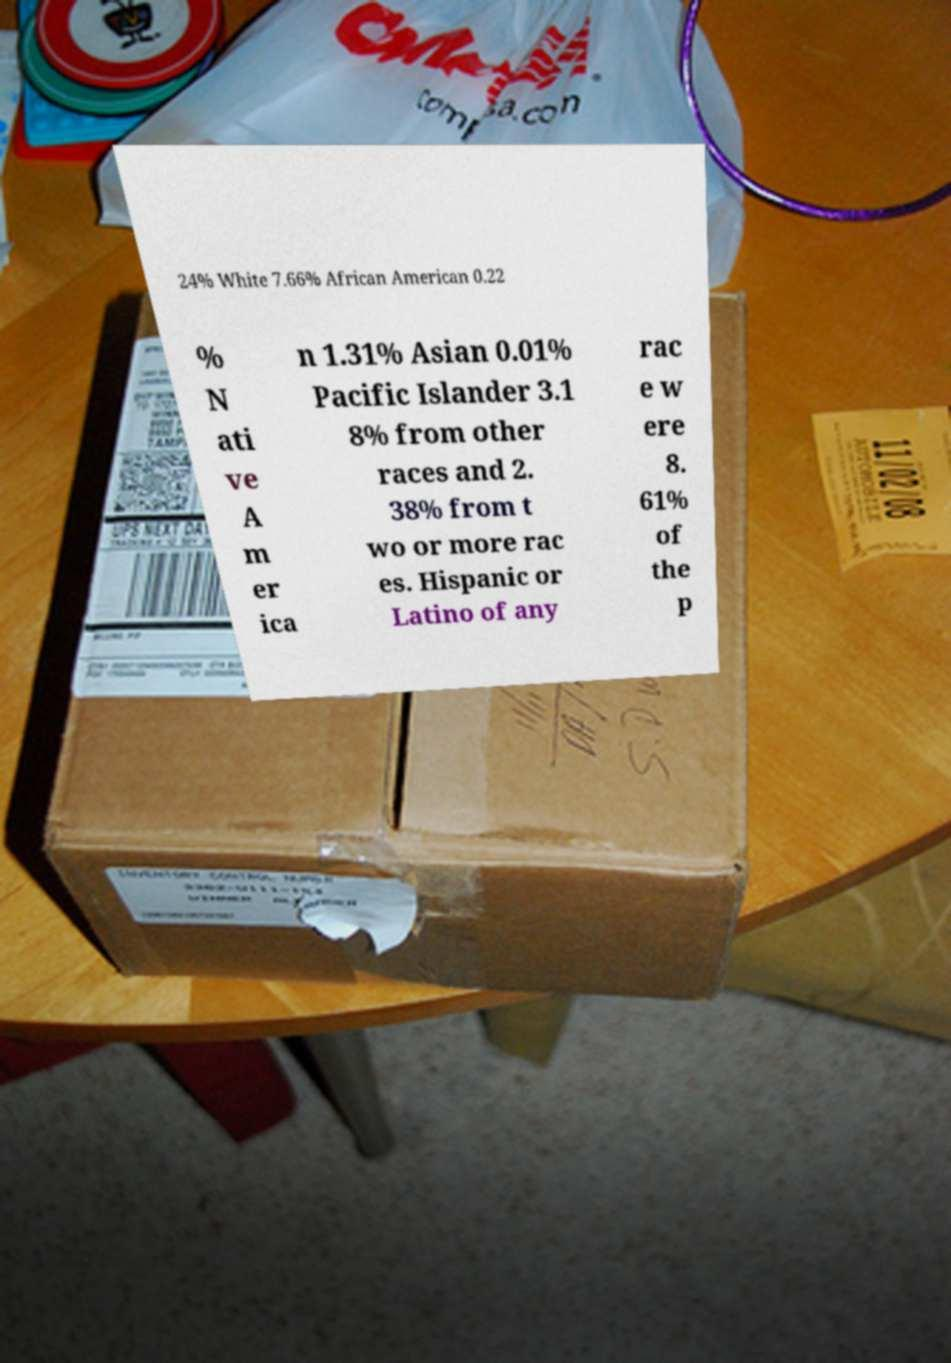Can you accurately transcribe the text from the provided image for me? 24% White 7.66% African American 0.22 % N ati ve A m er ica n 1.31% Asian 0.01% Pacific Islander 3.1 8% from other races and 2. 38% from t wo or more rac es. Hispanic or Latino of any rac e w ere 8. 61% of the p 